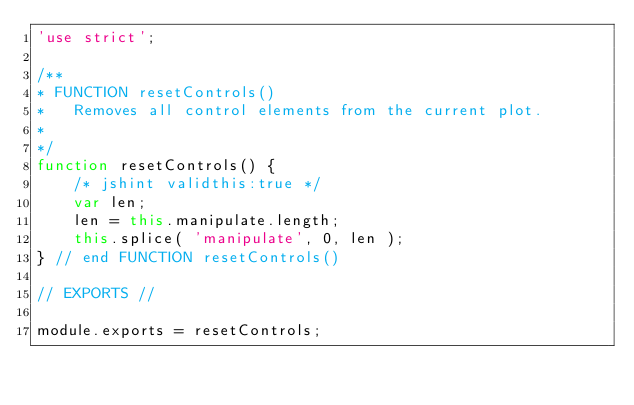Convert code to text. <code><loc_0><loc_0><loc_500><loc_500><_JavaScript_>'use strict';

/**
* FUNCTION resetControls()
*	Removes all control elements from the current plot.
*
*/
function resetControls() {
	/* jshint validthis:true */
	var len;
	len = this.manipulate.length;
	this.splice( 'manipulate', 0, len );
} // end FUNCTION resetControls()

// EXPORTS //

module.exports = resetControls;
</code> 